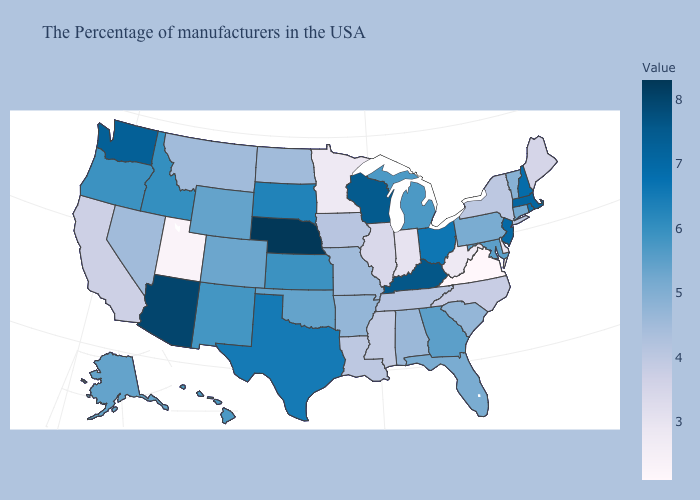Is the legend a continuous bar?
Give a very brief answer. Yes. Among the states that border Maryland , does Delaware have the highest value?
Be succinct. No. Which states have the lowest value in the MidWest?
Short answer required. Minnesota. Does Arizona have the highest value in the USA?
Write a very short answer. No. Which states hav the highest value in the West?
Quick response, please. Arizona. 